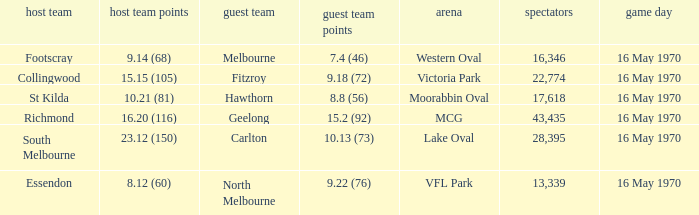Who was the away team at western oval? Melbourne. 